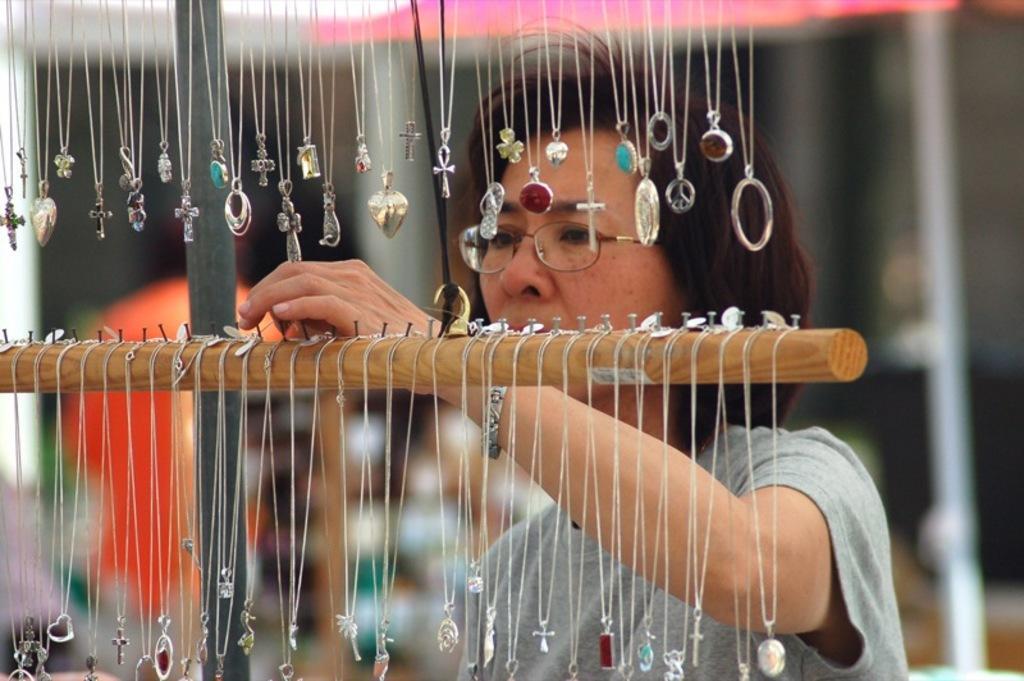Describe this image in one or two sentences. In this image we can see different kinds of chains hanged to the hangers with the help of hooks and a woman watching them. 